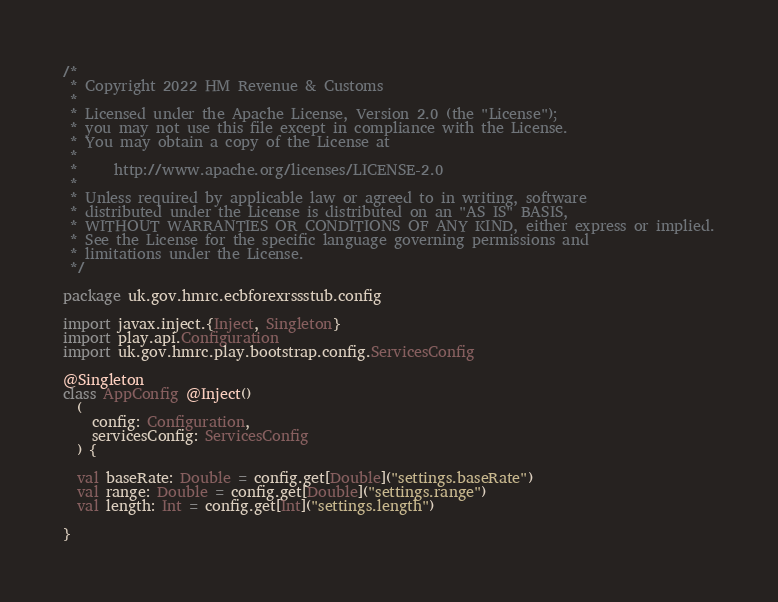Convert code to text. <code><loc_0><loc_0><loc_500><loc_500><_Scala_>/*
 * Copyright 2022 HM Revenue & Customs
 *
 * Licensed under the Apache License, Version 2.0 (the "License");
 * you may not use this file except in compliance with the License.
 * You may obtain a copy of the License at
 *
 *     http://www.apache.org/licenses/LICENSE-2.0
 *
 * Unless required by applicable law or agreed to in writing, software
 * distributed under the License is distributed on an "AS IS" BASIS,
 * WITHOUT WARRANTIES OR CONDITIONS OF ANY KIND, either express or implied.
 * See the License for the specific language governing permissions and
 * limitations under the License.
 */

package uk.gov.hmrc.ecbforexrssstub.config

import javax.inject.{Inject, Singleton}
import play.api.Configuration
import uk.gov.hmrc.play.bootstrap.config.ServicesConfig

@Singleton
class AppConfig @Inject()
  (
    config: Configuration,
    servicesConfig: ServicesConfig
  ) {

  val baseRate: Double = config.get[Double]("settings.baseRate")
  val range: Double = config.get[Double]("settings.range")
  val length: Int = config.get[Int]("settings.length")

}
</code> 